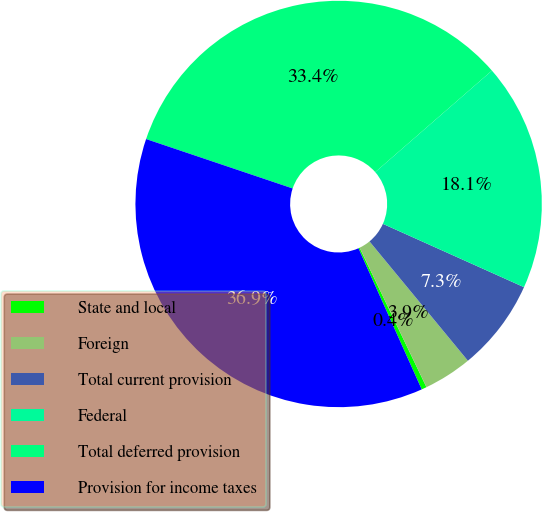Convert chart. <chart><loc_0><loc_0><loc_500><loc_500><pie_chart><fcel>State and local<fcel>Foreign<fcel>Total current provision<fcel>Federal<fcel>Total deferred provision<fcel>Provision for income taxes<nl><fcel>0.41%<fcel>3.86%<fcel>7.31%<fcel>18.11%<fcel>33.43%<fcel>36.88%<nl></chart> 